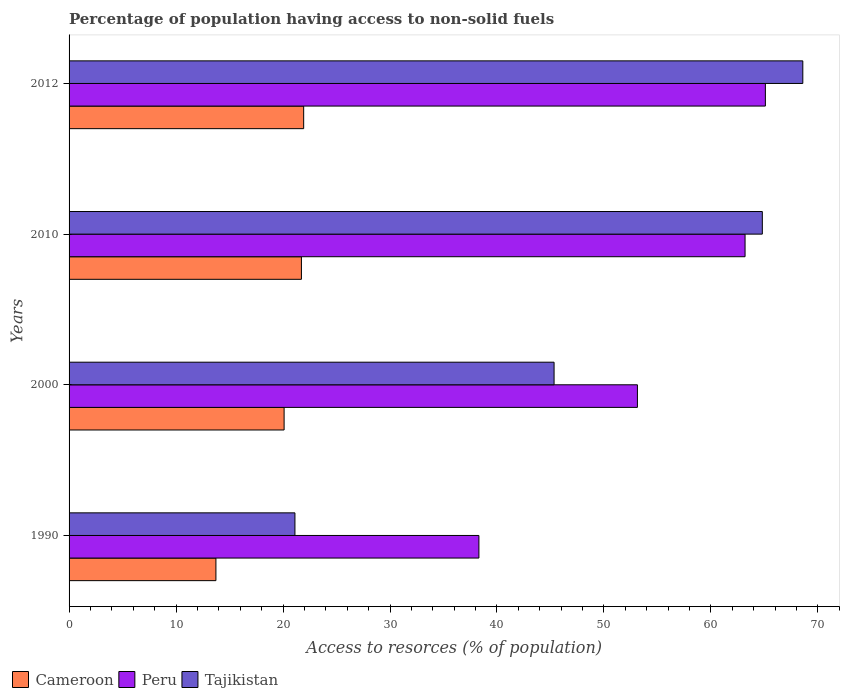How many different coloured bars are there?
Your response must be concise. 3. Are the number of bars per tick equal to the number of legend labels?
Keep it short and to the point. Yes. Are the number of bars on each tick of the Y-axis equal?
Provide a succinct answer. Yes. How many bars are there on the 3rd tick from the top?
Give a very brief answer. 3. What is the label of the 2nd group of bars from the top?
Provide a short and direct response. 2010. In how many cases, is the number of bars for a given year not equal to the number of legend labels?
Ensure brevity in your answer.  0. What is the percentage of population having access to non-solid fuels in Cameroon in 1990?
Give a very brief answer. 13.73. Across all years, what is the maximum percentage of population having access to non-solid fuels in Cameroon?
Offer a terse response. 21.93. Across all years, what is the minimum percentage of population having access to non-solid fuels in Tajikistan?
Keep it short and to the point. 21.11. What is the total percentage of population having access to non-solid fuels in Peru in the graph?
Ensure brevity in your answer.  219.71. What is the difference between the percentage of population having access to non-solid fuels in Peru in 1990 and that in 2010?
Your response must be concise. -24.88. What is the difference between the percentage of population having access to non-solid fuels in Tajikistan in 1990 and the percentage of population having access to non-solid fuels in Peru in 2012?
Offer a very short reply. -43.98. What is the average percentage of population having access to non-solid fuels in Tajikistan per year?
Your response must be concise. 49.96. In the year 1990, what is the difference between the percentage of population having access to non-solid fuels in Tajikistan and percentage of population having access to non-solid fuels in Cameroon?
Offer a very short reply. 7.38. What is the ratio of the percentage of population having access to non-solid fuels in Peru in 1990 to that in 2010?
Your response must be concise. 0.61. Is the percentage of population having access to non-solid fuels in Cameroon in 1990 less than that in 2010?
Ensure brevity in your answer.  Yes. What is the difference between the highest and the second highest percentage of population having access to non-solid fuels in Tajikistan?
Ensure brevity in your answer.  3.78. What is the difference between the highest and the lowest percentage of population having access to non-solid fuels in Tajikistan?
Your answer should be compact. 47.47. In how many years, is the percentage of population having access to non-solid fuels in Peru greater than the average percentage of population having access to non-solid fuels in Peru taken over all years?
Make the answer very short. 2. Is the sum of the percentage of population having access to non-solid fuels in Cameroon in 1990 and 2000 greater than the maximum percentage of population having access to non-solid fuels in Peru across all years?
Offer a terse response. No. What does the 2nd bar from the top in 2012 represents?
Offer a very short reply. Peru. What does the 3rd bar from the bottom in 2010 represents?
Keep it short and to the point. Tajikistan. How many years are there in the graph?
Ensure brevity in your answer.  4. Does the graph contain any zero values?
Your response must be concise. No. Does the graph contain grids?
Your answer should be compact. No. Where does the legend appear in the graph?
Provide a short and direct response. Bottom left. How many legend labels are there?
Your response must be concise. 3. What is the title of the graph?
Provide a short and direct response. Percentage of population having access to non-solid fuels. What is the label or title of the X-axis?
Keep it short and to the point. Access to resorces (% of population). What is the label or title of the Y-axis?
Ensure brevity in your answer.  Years. What is the Access to resorces (% of population) of Cameroon in 1990?
Your answer should be very brief. 13.73. What is the Access to resorces (% of population) of Peru in 1990?
Your answer should be very brief. 38.31. What is the Access to resorces (% of population) of Tajikistan in 1990?
Provide a short and direct response. 21.11. What is the Access to resorces (% of population) in Cameroon in 2000?
Your answer should be very brief. 20.1. What is the Access to resorces (% of population) in Peru in 2000?
Give a very brief answer. 53.13. What is the Access to resorces (% of population) in Tajikistan in 2000?
Provide a short and direct response. 45.34. What is the Access to resorces (% of population) in Cameroon in 2010?
Offer a terse response. 21.72. What is the Access to resorces (% of population) of Peru in 2010?
Make the answer very short. 63.19. What is the Access to resorces (% of population) of Tajikistan in 2010?
Provide a short and direct response. 64.8. What is the Access to resorces (% of population) of Cameroon in 2012?
Offer a terse response. 21.93. What is the Access to resorces (% of population) in Peru in 2012?
Give a very brief answer. 65.09. What is the Access to resorces (% of population) of Tajikistan in 2012?
Provide a short and direct response. 68.59. Across all years, what is the maximum Access to resorces (% of population) of Cameroon?
Make the answer very short. 21.93. Across all years, what is the maximum Access to resorces (% of population) of Peru?
Your answer should be compact. 65.09. Across all years, what is the maximum Access to resorces (% of population) of Tajikistan?
Make the answer very short. 68.59. Across all years, what is the minimum Access to resorces (% of population) in Cameroon?
Your response must be concise. 13.73. Across all years, what is the minimum Access to resorces (% of population) in Peru?
Your answer should be compact. 38.31. Across all years, what is the minimum Access to resorces (% of population) in Tajikistan?
Offer a very short reply. 21.11. What is the total Access to resorces (% of population) in Cameroon in the graph?
Your response must be concise. 77.48. What is the total Access to resorces (% of population) of Peru in the graph?
Keep it short and to the point. 219.71. What is the total Access to resorces (% of population) in Tajikistan in the graph?
Your response must be concise. 199.84. What is the difference between the Access to resorces (% of population) in Cameroon in 1990 and that in 2000?
Give a very brief answer. -6.37. What is the difference between the Access to resorces (% of population) in Peru in 1990 and that in 2000?
Give a very brief answer. -14.82. What is the difference between the Access to resorces (% of population) in Tajikistan in 1990 and that in 2000?
Ensure brevity in your answer.  -24.22. What is the difference between the Access to resorces (% of population) of Cameroon in 1990 and that in 2010?
Provide a succinct answer. -7.99. What is the difference between the Access to resorces (% of population) in Peru in 1990 and that in 2010?
Your response must be concise. -24.88. What is the difference between the Access to resorces (% of population) in Tajikistan in 1990 and that in 2010?
Offer a very short reply. -43.69. What is the difference between the Access to resorces (% of population) of Cameroon in 1990 and that in 2012?
Make the answer very short. -8.2. What is the difference between the Access to resorces (% of population) of Peru in 1990 and that in 2012?
Offer a very short reply. -26.78. What is the difference between the Access to resorces (% of population) in Tajikistan in 1990 and that in 2012?
Offer a very short reply. -47.47. What is the difference between the Access to resorces (% of population) in Cameroon in 2000 and that in 2010?
Ensure brevity in your answer.  -1.62. What is the difference between the Access to resorces (% of population) of Peru in 2000 and that in 2010?
Your answer should be compact. -10.06. What is the difference between the Access to resorces (% of population) in Tajikistan in 2000 and that in 2010?
Your answer should be compact. -19.47. What is the difference between the Access to resorces (% of population) in Cameroon in 2000 and that in 2012?
Your answer should be compact. -1.83. What is the difference between the Access to resorces (% of population) of Peru in 2000 and that in 2012?
Keep it short and to the point. -11.96. What is the difference between the Access to resorces (% of population) in Tajikistan in 2000 and that in 2012?
Offer a terse response. -23.25. What is the difference between the Access to resorces (% of population) of Cameroon in 2010 and that in 2012?
Make the answer very short. -0.21. What is the difference between the Access to resorces (% of population) of Peru in 2010 and that in 2012?
Your answer should be very brief. -1.9. What is the difference between the Access to resorces (% of population) of Tajikistan in 2010 and that in 2012?
Provide a short and direct response. -3.78. What is the difference between the Access to resorces (% of population) in Cameroon in 1990 and the Access to resorces (% of population) in Peru in 2000?
Offer a very short reply. -39.4. What is the difference between the Access to resorces (% of population) of Cameroon in 1990 and the Access to resorces (% of population) of Tajikistan in 2000?
Ensure brevity in your answer.  -31.61. What is the difference between the Access to resorces (% of population) in Peru in 1990 and the Access to resorces (% of population) in Tajikistan in 2000?
Offer a terse response. -7.03. What is the difference between the Access to resorces (% of population) of Cameroon in 1990 and the Access to resorces (% of population) of Peru in 2010?
Ensure brevity in your answer.  -49.46. What is the difference between the Access to resorces (% of population) in Cameroon in 1990 and the Access to resorces (% of population) in Tajikistan in 2010?
Offer a terse response. -51.08. What is the difference between the Access to resorces (% of population) of Peru in 1990 and the Access to resorces (% of population) of Tajikistan in 2010?
Ensure brevity in your answer.  -26.49. What is the difference between the Access to resorces (% of population) in Cameroon in 1990 and the Access to resorces (% of population) in Peru in 2012?
Offer a terse response. -51.36. What is the difference between the Access to resorces (% of population) of Cameroon in 1990 and the Access to resorces (% of population) of Tajikistan in 2012?
Ensure brevity in your answer.  -54.86. What is the difference between the Access to resorces (% of population) in Peru in 1990 and the Access to resorces (% of population) in Tajikistan in 2012?
Make the answer very short. -30.28. What is the difference between the Access to resorces (% of population) in Cameroon in 2000 and the Access to resorces (% of population) in Peru in 2010?
Your answer should be compact. -43.09. What is the difference between the Access to resorces (% of population) in Cameroon in 2000 and the Access to resorces (% of population) in Tajikistan in 2010?
Ensure brevity in your answer.  -44.7. What is the difference between the Access to resorces (% of population) of Peru in 2000 and the Access to resorces (% of population) of Tajikistan in 2010?
Offer a very short reply. -11.68. What is the difference between the Access to resorces (% of population) of Cameroon in 2000 and the Access to resorces (% of population) of Peru in 2012?
Keep it short and to the point. -44.99. What is the difference between the Access to resorces (% of population) in Cameroon in 2000 and the Access to resorces (% of population) in Tajikistan in 2012?
Provide a succinct answer. -48.49. What is the difference between the Access to resorces (% of population) of Peru in 2000 and the Access to resorces (% of population) of Tajikistan in 2012?
Make the answer very short. -15.46. What is the difference between the Access to resorces (% of population) of Cameroon in 2010 and the Access to resorces (% of population) of Peru in 2012?
Provide a short and direct response. -43.37. What is the difference between the Access to resorces (% of population) of Cameroon in 2010 and the Access to resorces (% of population) of Tajikistan in 2012?
Give a very brief answer. -46.87. What is the difference between the Access to resorces (% of population) in Peru in 2010 and the Access to resorces (% of population) in Tajikistan in 2012?
Your response must be concise. -5.4. What is the average Access to resorces (% of population) in Cameroon per year?
Your answer should be compact. 19.37. What is the average Access to resorces (% of population) of Peru per year?
Provide a succinct answer. 54.93. What is the average Access to resorces (% of population) in Tajikistan per year?
Give a very brief answer. 49.96. In the year 1990, what is the difference between the Access to resorces (% of population) in Cameroon and Access to resorces (% of population) in Peru?
Your answer should be very brief. -24.58. In the year 1990, what is the difference between the Access to resorces (% of population) of Cameroon and Access to resorces (% of population) of Tajikistan?
Your answer should be very brief. -7.38. In the year 1990, what is the difference between the Access to resorces (% of population) in Peru and Access to resorces (% of population) in Tajikistan?
Your response must be concise. 17.2. In the year 2000, what is the difference between the Access to resorces (% of population) of Cameroon and Access to resorces (% of population) of Peru?
Keep it short and to the point. -33.03. In the year 2000, what is the difference between the Access to resorces (% of population) in Cameroon and Access to resorces (% of population) in Tajikistan?
Offer a very short reply. -25.24. In the year 2000, what is the difference between the Access to resorces (% of population) of Peru and Access to resorces (% of population) of Tajikistan?
Ensure brevity in your answer.  7.79. In the year 2010, what is the difference between the Access to resorces (% of population) in Cameroon and Access to resorces (% of population) in Peru?
Your answer should be compact. -41.47. In the year 2010, what is the difference between the Access to resorces (% of population) of Cameroon and Access to resorces (% of population) of Tajikistan?
Your response must be concise. -43.08. In the year 2010, what is the difference between the Access to resorces (% of population) in Peru and Access to resorces (% of population) in Tajikistan?
Offer a terse response. -1.61. In the year 2012, what is the difference between the Access to resorces (% of population) of Cameroon and Access to resorces (% of population) of Peru?
Provide a succinct answer. -43.16. In the year 2012, what is the difference between the Access to resorces (% of population) in Cameroon and Access to resorces (% of population) in Tajikistan?
Provide a short and direct response. -46.66. In the year 2012, what is the difference between the Access to resorces (% of population) of Peru and Access to resorces (% of population) of Tajikistan?
Make the answer very short. -3.5. What is the ratio of the Access to resorces (% of population) in Cameroon in 1990 to that in 2000?
Ensure brevity in your answer.  0.68. What is the ratio of the Access to resorces (% of population) of Peru in 1990 to that in 2000?
Provide a short and direct response. 0.72. What is the ratio of the Access to resorces (% of population) of Tajikistan in 1990 to that in 2000?
Keep it short and to the point. 0.47. What is the ratio of the Access to resorces (% of population) in Cameroon in 1990 to that in 2010?
Offer a terse response. 0.63. What is the ratio of the Access to resorces (% of population) of Peru in 1990 to that in 2010?
Your answer should be very brief. 0.61. What is the ratio of the Access to resorces (% of population) of Tajikistan in 1990 to that in 2010?
Your response must be concise. 0.33. What is the ratio of the Access to resorces (% of population) of Cameroon in 1990 to that in 2012?
Offer a very short reply. 0.63. What is the ratio of the Access to resorces (% of population) in Peru in 1990 to that in 2012?
Ensure brevity in your answer.  0.59. What is the ratio of the Access to resorces (% of population) of Tajikistan in 1990 to that in 2012?
Make the answer very short. 0.31. What is the ratio of the Access to resorces (% of population) of Cameroon in 2000 to that in 2010?
Your response must be concise. 0.93. What is the ratio of the Access to resorces (% of population) of Peru in 2000 to that in 2010?
Offer a very short reply. 0.84. What is the ratio of the Access to resorces (% of population) of Tajikistan in 2000 to that in 2010?
Your answer should be very brief. 0.7. What is the ratio of the Access to resorces (% of population) of Cameroon in 2000 to that in 2012?
Ensure brevity in your answer.  0.92. What is the ratio of the Access to resorces (% of population) in Peru in 2000 to that in 2012?
Make the answer very short. 0.82. What is the ratio of the Access to resorces (% of population) in Tajikistan in 2000 to that in 2012?
Offer a terse response. 0.66. What is the ratio of the Access to resorces (% of population) in Cameroon in 2010 to that in 2012?
Offer a terse response. 0.99. What is the ratio of the Access to resorces (% of population) in Peru in 2010 to that in 2012?
Provide a succinct answer. 0.97. What is the ratio of the Access to resorces (% of population) of Tajikistan in 2010 to that in 2012?
Ensure brevity in your answer.  0.94. What is the difference between the highest and the second highest Access to resorces (% of population) of Cameroon?
Provide a short and direct response. 0.21. What is the difference between the highest and the second highest Access to resorces (% of population) in Peru?
Your answer should be compact. 1.9. What is the difference between the highest and the second highest Access to resorces (% of population) of Tajikistan?
Make the answer very short. 3.78. What is the difference between the highest and the lowest Access to resorces (% of population) of Cameroon?
Your answer should be very brief. 8.2. What is the difference between the highest and the lowest Access to resorces (% of population) in Peru?
Provide a short and direct response. 26.78. What is the difference between the highest and the lowest Access to resorces (% of population) in Tajikistan?
Offer a terse response. 47.47. 